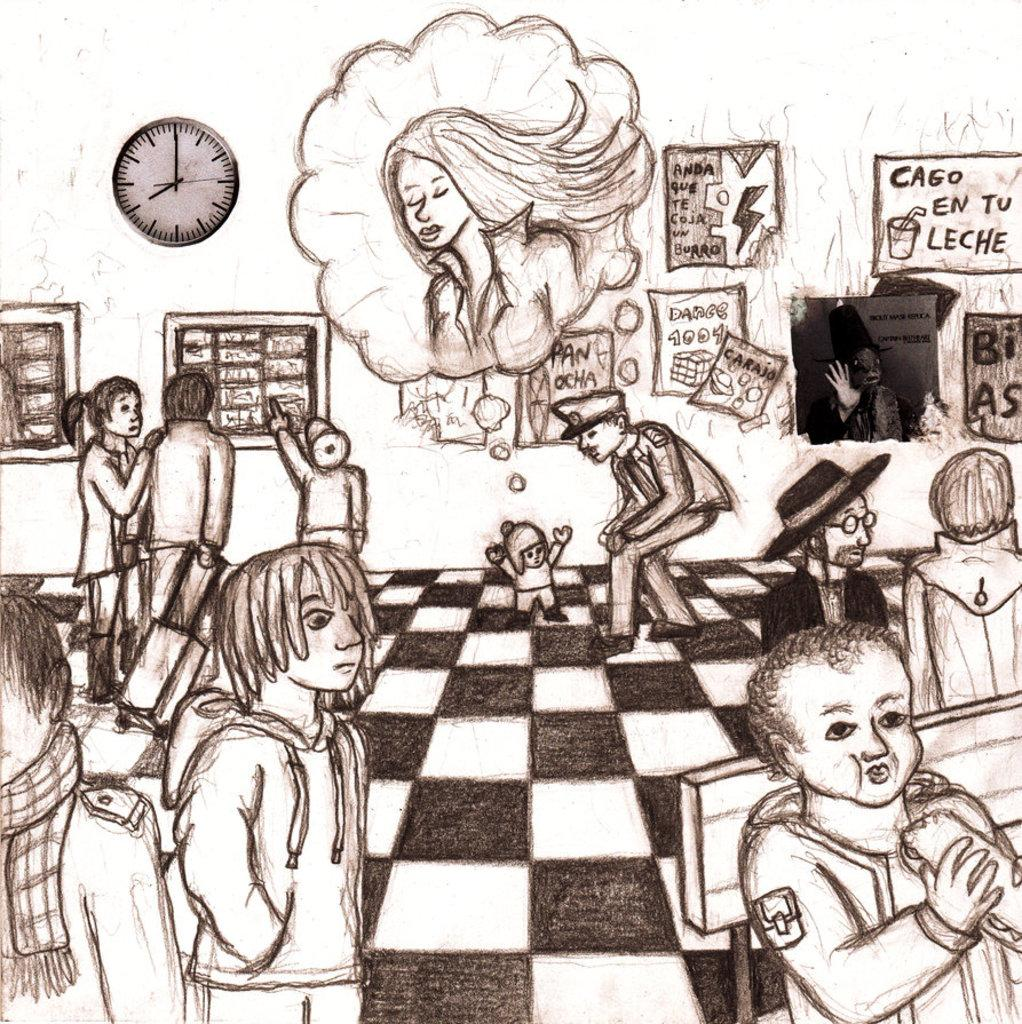<image>
Present a compact description of the photo's key features. Drawing of a police man next to a poster which says "Cago En Tu Leche". 